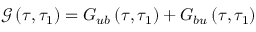<formula> <loc_0><loc_0><loc_500><loc_500>\mathcal { G } \left ( \tau , \tau _ { 1 } \right ) = G _ { u b } \left ( \tau , \tau _ { 1 } \right ) + G _ { b u } \left ( \tau , \tau _ { 1 } \right )</formula> 